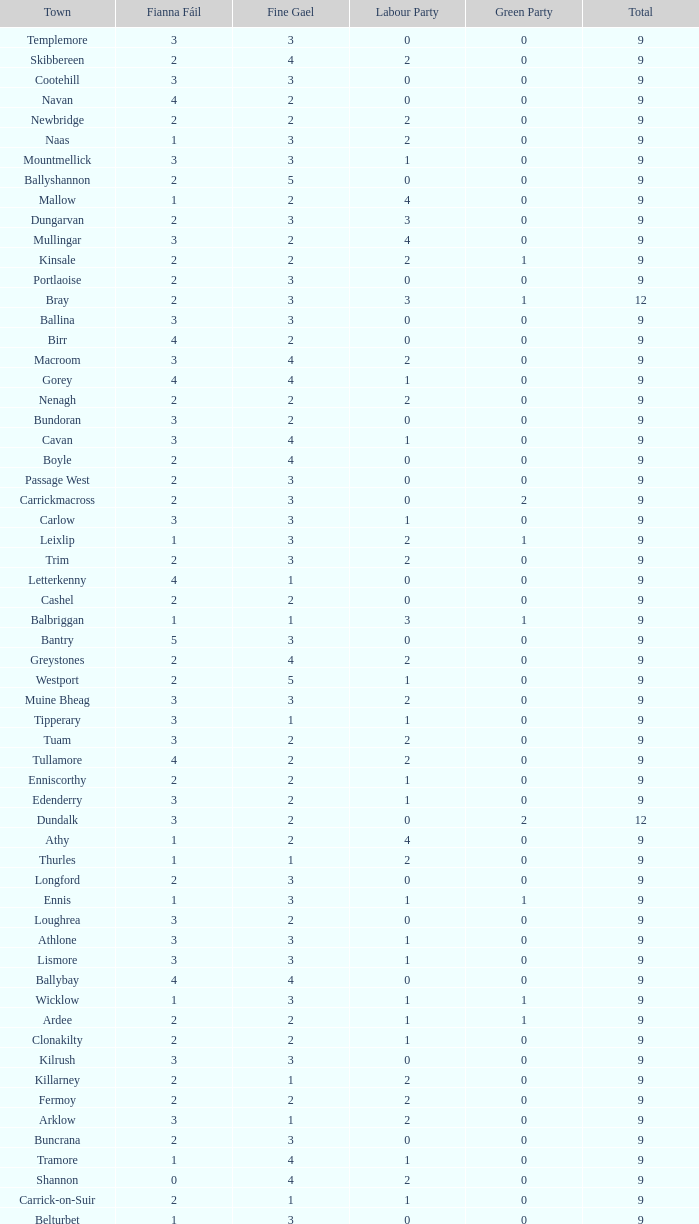What is the lowest number in the Labour Party for the Fianna Fail higher than 5? None. 